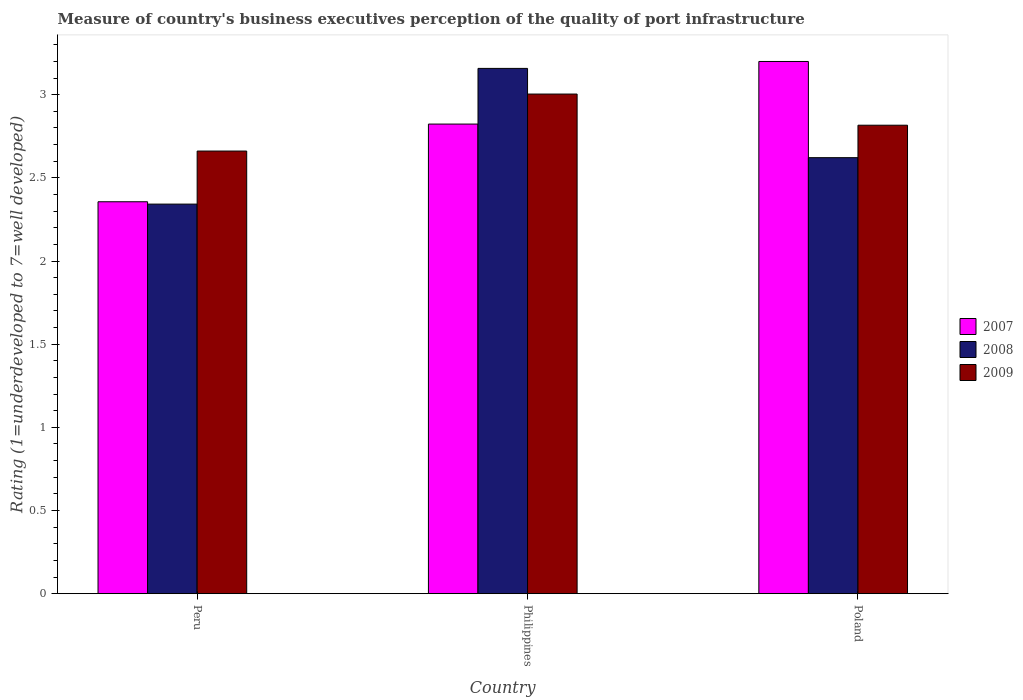How many different coloured bars are there?
Offer a very short reply. 3. How many groups of bars are there?
Offer a very short reply. 3. Are the number of bars per tick equal to the number of legend labels?
Offer a very short reply. Yes. Are the number of bars on each tick of the X-axis equal?
Provide a short and direct response. Yes. What is the label of the 3rd group of bars from the left?
Make the answer very short. Poland. In how many cases, is the number of bars for a given country not equal to the number of legend labels?
Keep it short and to the point. 0. What is the ratings of the quality of port infrastructure in 2007 in Peru?
Give a very brief answer. 2.36. Across all countries, what is the maximum ratings of the quality of port infrastructure in 2009?
Give a very brief answer. 3. Across all countries, what is the minimum ratings of the quality of port infrastructure in 2007?
Ensure brevity in your answer.  2.36. In which country was the ratings of the quality of port infrastructure in 2007 maximum?
Offer a terse response. Poland. What is the total ratings of the quality of port infrastructure in 2007 in the graph?
Keep it short and to the point. 8.38. What is the difference between the ratings of the quality of port infrastructure in 2009 in Philippines and that in Poland?
Your answer should be very brief. 0.19. What is the difference between the ratings of the quality of port infrastructure in 2007 in Poland and the ratings of the quality of port infrastructure in 2009 in Philippines?
Provide a short and direct response. 0.2. What is the average ratings of the quality of port infrastructure in 2009 per country?
Ensure brevity in your answer.  2.83. What is the difference between the ratings of the quality of port infrastructure of/in 2007 and ratings of the quality of port infrastructure of/in 2008 in Poland?
Offer a terse response. 0.58. What is the ratio of the ratings of the quality of port infrastructure in 2009 in Peru to that in Philippines?
Keep it short and to the point. 0.89. Is the ratings of the quality of port infrastructure in 2007 in Philippines less than that in Poland?
Your answer should be compact. Yes. What is the difference between the highest and the second highest ratings of the quality of port infrastructure in 2007?
Offer a very short reply. -0.47. What is the difference between the highest and the lowest ratings of the quality of port infrastructure in 2008?
Provide a short and direct response. 0.82. In how many countries, is the ratings of the quality of port infrastructure in 2009 greater than the average ratings of the quality of port infrastructure in 2009 taken over all countries?
Make the answer very short. 1. How many countries are there in the graph?
Keep it short and to the point. 3. Are the values on the major ticks of Y-axis written in scientific E-notation?
Make the answer very short. No. Does the graph contain grids?
Make the answer very short. No. Where does the legend appear in the graph?
Give a very brief answer. Center right. How many legend labels are there?
Your response must be concise. 3. What is the title of the graph?
Ensure brevity in your answer.  Measure of country's business executives perception of the quality of port infrastructure. Does "1984" appear as one of the legend labels in the graph?
Offer a terse response. No. What is the label or title of the X-axis?
Your response must be concise. Country. What is the label or title of the Y-axis?
Provide a short and direct response. Rating (1=underdeveloped to 7=well developed). What is the Rating (1=underdeveloped to 7=well developed) in 2007 in Peru?
Make the answer very short. 2.36. What is the Rating (1=underdeveloped to 7=well developed) of 2008 in Peru?
Offer a very short reply. 2.34. What is the Rating (1=underdeveloped to 7=well developed) of 2009 in Peru?
Make the answer very short. 2.66. What is the Rating (1=underdeveloped to 7=well developed) in 2007 in Philippines?
Offer a very short reply. 2.82. What is the Rating (1=underdeveloped to 7=well developed) of 2008 in Philippines?
Your answer should be very brief. 3.16. What is the Rating (1=underdeveloped to 7=well developed) of 2009 in Philippines?
Ensure brevity in your answer.  3. What is the Rating (1=underdeveloped to 7=well developed) in 2007 in Poland?
Your answer should be very brief. 3.2. What is the Rating (1=underdeveloped to 7=well developed) of 2008 in Poland?
Provide a succinct answer. 2.62. What is the Rating (1=underdeveloped to 7=well developed) in 2009 in Poland?
Make the answer very short. 2.82. Across all countries, what is the maximum Rating (1=underdeveloped to 7=well developed) in 2007?
Make the answer very short. 3.2. Across all countries, what is the maximum Rating (1=underdeveloped to 7=well developed) in 2008?
Your answer should be compact. 3.16. Across all countries, what is the maximum Rating (1=underdeveloped to 7=well developed) of 2009?
Keep it short and to the point. 3. Across all countries, what is the minimum Rating (1=underdeveloped to 7=well developed) of 2007?
Ensure brevity in your answer.  2.36. Across all countries, what is the minimum Rating (1=underdeveloped to 7=well developed) of 2008?
Give a very brief answer. 2.34. Across all countries, what is the minimum Rating (1=underdeveloped to 7=well developed) of 2009?
Your answer should be compact. 2.66. What is the total Rating (1=underdeveloped to 7=well developed) in 2007 in the graph?
Provide a short and direct response. 8.38. What is the total Rating (1=underdeveloped to 7=well developed) of 2008 in the graph?
Your answer should be compact. 8.12. What is the total Rating (1=underdeveloped to 7=well developed) in 2009 in the graph?
Offer a very short reply. 8.48. What is the difference between the Rating (1=underdeveloped to 7=well developed) of 2007 in Peru and that in Philippines?
Make the answer very short. -0.47. What is the difference between the Rating (1=underdeveloped to 7=well developed) in 2008 in Peru and that in Philippines?
Ensure brevity in your answer.  -0.82. What is the difference between the Rating (1=underdeveloped to 7=well developed) in 2009 in Peru and that in Philippines?
Keep it short and to the point. -0.34. What is the difference between the Rating (1=underdeveloped to 7=well developed) in 2007 in Peru and that in Poland?
Ensure brevity in your answer.  -0.84. What is the difference between the Rating (1=underdeveloped to 7=well developed) in 2008 in Peru and that in Poland?
Ensure brevity in your answer.  -0.28. What is the difference between the Rating (1=underdeveloped to 7=well developed) of 2009 in Peru and that in Poland?
Make the answer very short. -0.16. What is the difference between the Rating (1=underdeveloped to 7=well developed) of 2007 in Philippines and that in Poland?
Provide a short and direct response. -0.38. What is the difference between the Rating (1=underdeveloped to 7=well developed) in 2008 in Philippines and that in Poland?
Provide a short and direct response. 0.54. What is the difference between the Rating (1=underdeveloped to 7=well developed) in 2009 in Philippines and that in Poland?
Your answer should be very brief. 0.19. What is the difference between the Rating (1=underdeveloped to 7=well developed) in 2007 in Peru and the Rating (1=underdeveloped to 7=well developed) in 2008 in Philippines?
Your response must be concise. -0.8. What is the difference between the Rating (1=underdeveloped to 7=well developed) of 2007 in Peru and the Rating (1=underdeveloped to 7=well developed) of 2009 in Philippines?
Your answer should be compact. -0.65. What is the difference between the Rating (1=underdeveloped to 7=well developed) of 2008 in Peru and the Rating (1=underdeveloped to 7=well developed) of 2009 in Philippines?
Ensure brevity in your answer.  -0.66. What is the difference between the Rating (1=underdeveloped to 7=well developed) of 2007 in Peru and the Rating (1=underdeveloped to 7=well developed) of 2008 in Poland?
Offer a terse response. -0.27. What is the difference between the Rating (1=underdeveloped to 7=well developed) in 2007 in Peru and the Rating (1=underdeveloped to 7=well developed) in 2009 in Poland?
Provide a succinct answer. -0.46. What is the difference between the Rating (1=underdeveloped to 7=well developed) of 2008 in Peru and the Rating (1=underdeveloped to 7=well developed) of 2009 in Poland?
Ensure brevity in your answer.  -0.47. What is the difference between the Rating (1=underdeveloped to 7=well developed) in 2007 in Philippines and the Rating (1=underdeveloped to 7=well developed) in 2008 in Poland?
Your response must be concise. 0.2. What is the difference between the Rating (1=underdeveloped to 7=well developed) of 2007 in Philippines and the Rating (1=underdeveloped to 7=well developed) of 2009 in Poland?
Your answer should be compact. 0.01. What is the difference between the Rating (1=underdeveloped to 7=well developed) in 2008 in Philippines and the Rating (1=underdeveloped to 7=well developed) in 2009 in Poland?
Make the answer very short. 0.34. What is the average Rating (1=underdeveloped to 7=well developed) in 2007 per country?
Ensure brevity in your answer.  2.79. What is the average Rating (1=underdeveloped to 7=well developed) of 2008 per country?
Provide a short and direct response. 2.71. What is the average Rating (1=underdeveloped to 7=well developed) of 2009 per country?
Provide a short and direct response. 2.83. What is the difference between the Rating (1=underdeveloped to 7=well developed) of 2007 and Rating (1=underdeveloped to 7=well developed) of 2008 in Peru?
Your answer should be very brief. 0.01. What is the difference between the Rating (1=underdeveloped to 7=well developed) of 2007 and Rating (1=underdeveloped to 7=well developed) of 2009 in Peru?
Provide a succinct answer. -0.3. What is the difference between the Rating (1=underdeveloped to 7=well developed) of 2008 and Rating (1=underdeveloped to 7=well developed) of 2009 in Peru?
Provide a succinct answer. -0.32. What is the difference between the Rating (1=underdeveloped to 7=well developed) in 2007 and Rating (1=underdeveloped to 7=well developed) in 2008 in Philippines?
Give a very brief answer. -0.33. What is the difference between the Rating (1=underdeveloped to 7=well developed) of 2007 and Rating (1=underdeveloped to 7=well developed) of 2009 in Philippines?
Offer a terse response. -0.18. What is the difference between the Rating (1=underdeveloped to 7=well developed) in 2008 and Rating (1=underdeveloped to 7=well developed) in 2009 in Philippines?
Offer a very short reply. 0.15. What is the difference between the Rating (1=underdeveloped to 7=well developed) of 2007 and Rating (1=underdeveloped to 7=well developed) of 2008 in Poland?
Give a very brief answer. 0.58. What is the difference between the Rating (1=underdeveloped to 7=well developed) in 2007 and Rating (1=underdeveloped to 7=well developed) in 2009 in Poland?
Make the answer very short. 0.38. What is the difference between the Rating (1=underdeveloped to 7=well developed) in 2008 and Rating (1=underdeveloped to 7=well developed) in 2009 in Poland?
Your answer should be very brief. -0.2. What is the ratio of the Rating (1=underdeveloped to 7=well developed) in 2007 in Peru to that in Philippines?
Offer a very short reply. 0.83. What is the ratio of the Rating (1=underdeveloped to 7=well developed) in 2008 in Peru to that in Philippines?
Your response must be concise. 0.74. What is the ratio of the Rating (1=underdeveloped to 7=well developed) in 2009 in Peru to that in Philippines?
Give a very brief answer. 0.89. What is the ratio of the Rating (1=underdeveloped to 7=well developed) in 2007 in Peru to that in Poland?
Your answer should be very brief. 0.74. What is the ratio of the Rating (1=underdeveloped to 7=well developed) in 2008 in Peru to that in Poland?
Provide a short and direct response. 0.89. What is the ratio of the Rating (1=underdeveloped to 7=well developed) in 2009 in Peru to that in Poland?
Ensure brevity in your answer.  0.94. What is the ratio of the Rating (1=underdeveloped to 7=well developed) in 2007 in Philippines to that in Poland?
Keep it short and to the point. 0.88. What is the ratio of the Rating (1=underdeveloped to 7=well developed) in 2008 in Philippines to that in Poland?
Make the answer very short. 1.2. What is the ratio of the Rating (1=underdeveloped to 7=well developed) in 2009 in Philippines to that in Poland?
Your answer should be very brief. 1.07. What is the difference between the highest and the second highest Rating (1=underdeveloped to 7=well developed) in 2007?
Provide a succinct answer. 0.38. What is the difference between the highest and the second highest Rating (1=underdeveloped to 7=well developed) in 2008?
Provide a short and direct response. 0.54. What is the difference between the highest and the second highest Rating (1=underdeveloped to 7=well developed) in 2009?
Your answer should be compact. 0.19. What is the difference between the highest and the lowest Rating (1=underdeveloped to 7=well developed) of 2007?
Your answer should be compact. 0.84. What is the difference between the highest and the lowest Rating (1=underdeveloped to 7=well developed) of 2008?
Offer a very short reply. 0.82. What is the difference between the highest and the lowest Rating (1=underdeveloped to 7=well developed) in 2009?
Keep it short and to the point. 0.34. 